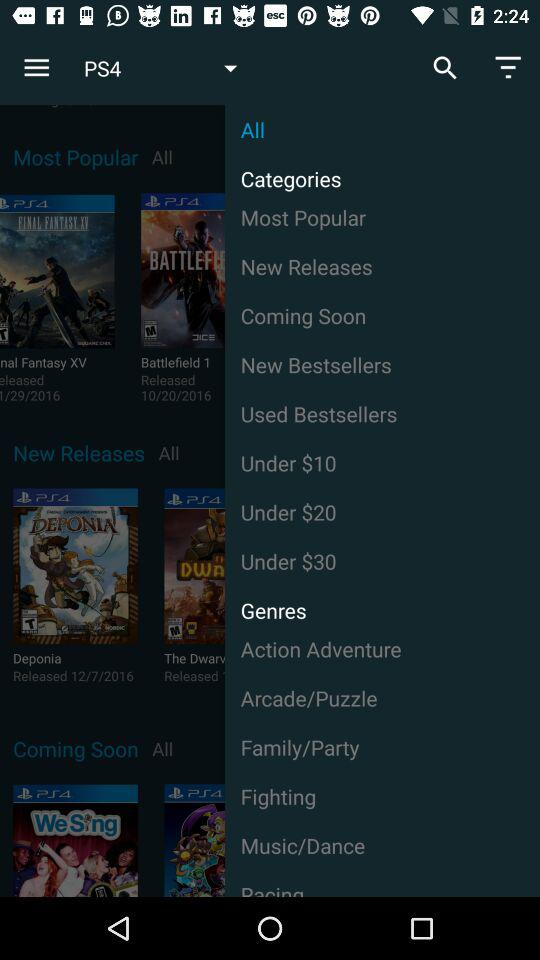Which category is selected?
When the provided information is insufficient, respond with <no answer>. <no answer> 